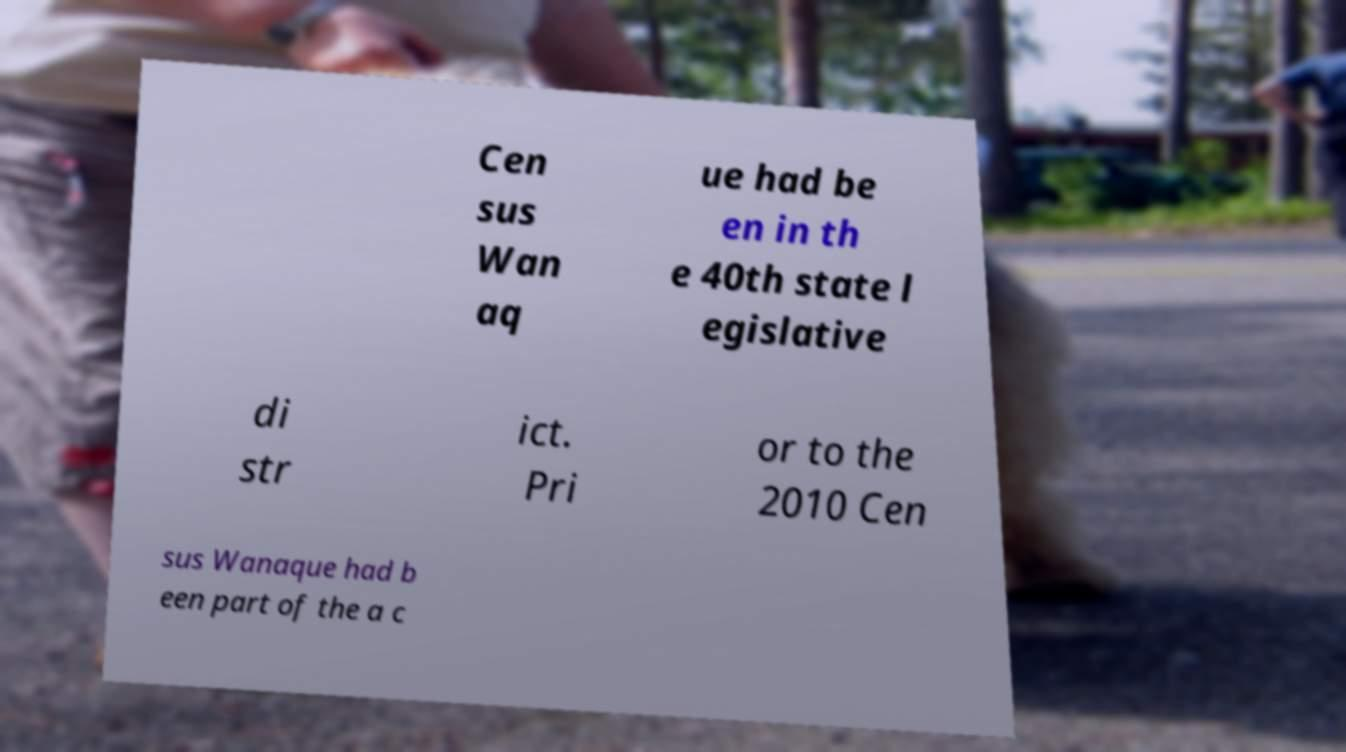Can you accurately transcribe the text from the provided image for me? Cen sus Wan aq ue had be en in th e 40th state l egislative di str ict. Pri or to the 2010 Cen sus Wanaque had b een part of the a c 